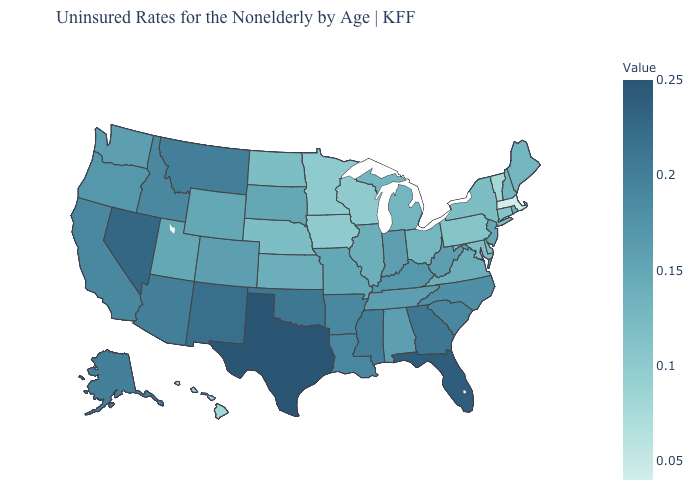Does Massachusetts have the lowest value in the USA?
Keep it brief. Yes. Does Maine have a higher value than Colorado?
Quick response, please. No. Is the legend a continuous bar?
Quick response, please. Yes. Which states have the lowest value in the USA?
Quick response, please. Massachusetts. Which states hav the highest value in the Northeast?
Keep it brief. New Jersey. Among the states that border Tennessee , does Virginia have the lowest value?
Keep it brief. Yes. 